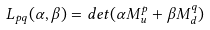<formula> <loc_0><loc_0><loc_500><loc_500>L _ { p q } ( \alpha , \beta ) = d e t ( \alpha M _ { u } ^ { p } + \beta M _ { d } ^ { q } )</formula> 